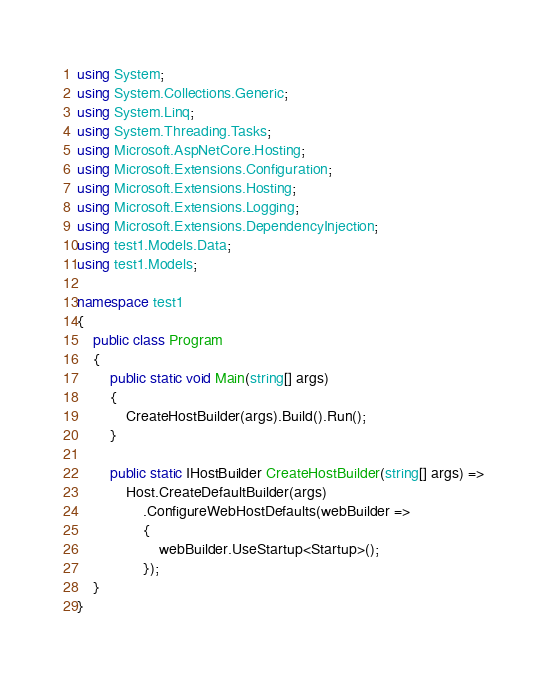<code> <loc_0><loc_0><loc_500><loc_500><_C#_>using System;
using System.Collections.Generic;
using System.Linq;
using System.Threading.Tasks;
using Microsoft.AspNetCore.Hosting;
using Microsoft.Extensions.Configuration;
using Microsoft.Extensions.Hosting;
using Microsoft.Extensions.Logging;
using Microsoft.Extensions.DependencyInjection;
using test1.Models.Data;
using test1.Models;

namespace test1
{
    public class Program
    {
        public static void Main(string[] args)
        {
            CreateHostBuilder(args).Build().Run();
        }

        public static IHostBuilder CreateHostBuilder(string[] args) =>
            Host.CreateDefaultBuilder(args)
                .ConfigureWebHostDefaults(webBuilder =>
                {
                    webBuilder.UseStartup<Startup>();
                });
    }
}
</code> 